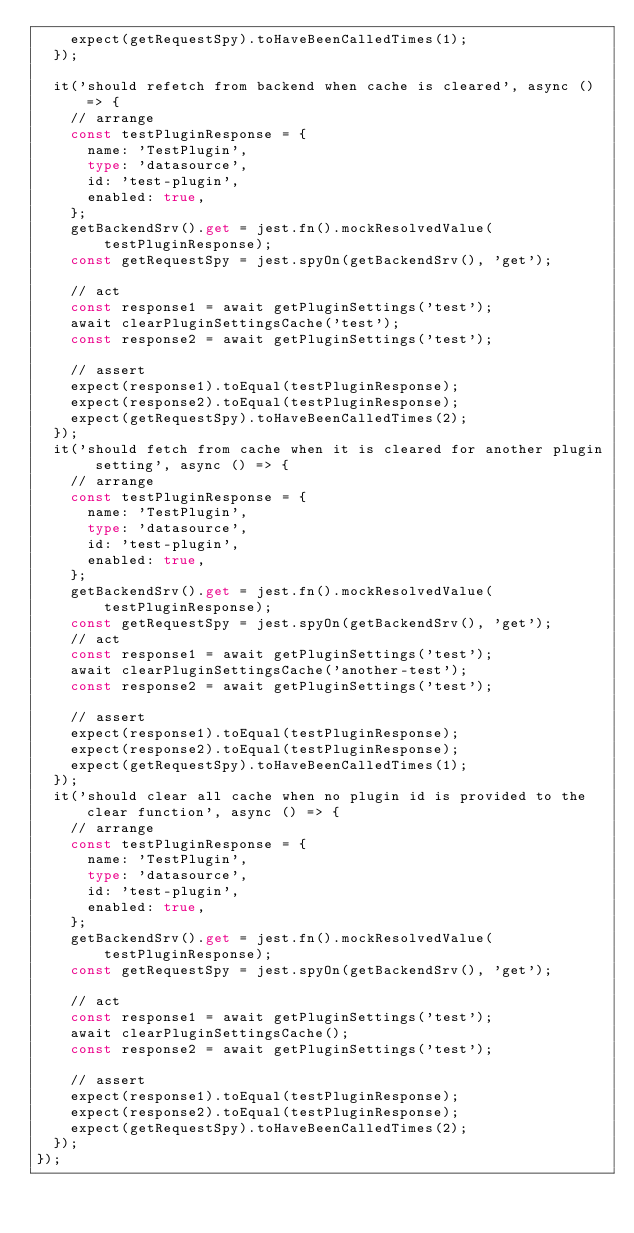Convert code to text. <code><loc_0><loc_0><loc_500><loc_500><_TypeScript_>    expect(getRequestSpy).toHaveBeenCalledTimes(1);
  });

  it('should refetch from backend when cache is cleared', async () => {
    // arrange
    const testPluginResponse = {
      name: 'TestPlugin',
      type: 'datasource',
      id: 'test-plugin',
      enabled: true,
    };
    getBackendSrv().get = jest.fn().mockResolvedValue(testPluginResponse);
    const getRequestSpy = jest.spyOn(getBackendSrv(), 'get');

    // act
    const response1 = await getPluginSettings('test');
    await clearPluginSettingsCache('test');
    const response2 = await getPluginSettings('test');

    // assert
    expect(response1).toEqual(testPluginResponse);
    expect(response2).toEqual(testPluginResponse);
    expect(getRequestSpy).toHaveBeenCalledTimes(2);
  });
  it('should fetch from cache when it is cleared for another plugin setting', async () => {
    // arrange
    const testPluginResponse = {
      name: 'TestPlugin',
      type: 'datasource',
      id: 'test-plugin',
      enabled: true,
    };
    getBackendSrv().get = jest.fn().mockResolvedValue(testPluginResponse);
    const getRequestSpy = jest.spyOn(getBackendSrv(), 'get');
    // act
    const response1 = await getPluginSettings('test');
    await clearPluginSettingsCache('another-test');
    const response2 = await getPluginSettings('test');

    // assert
    expect(response1).toEqual(testPluginResponse);
    expect(response2).toEqual(testPluginResponse);
    expect(getRequestSpy).toHaveBeenCalledTimes(1);
  });
  it('should clear all cache when no plugin id is provided to the clear function', async () => {
    // arrange
    const testPluginResponse = {
      name: 'TestPlugin',
      type: 'datasource',
      id: 'test-plugin',
      enabled: true,
    };
    getBackendSrv().get = jest.fn().mockResolvedValue(testPluginResponse);
    const getRequestSpy = jest.spyOn(getBackendSrv(), 'get');

    // act
    const response1 = await getPluginSettings('test');
    await clearPluginSettingsCache();
    const response2 = await getPluginSettings('test');

    // assert
    expect(response1).toEqual(testPluginResponse);
    expect(response2).toEqual(testPluginResponse);
    expect(getRequestSpy).toHaveBeenCalledTimes(2);
  });
});
</code> 